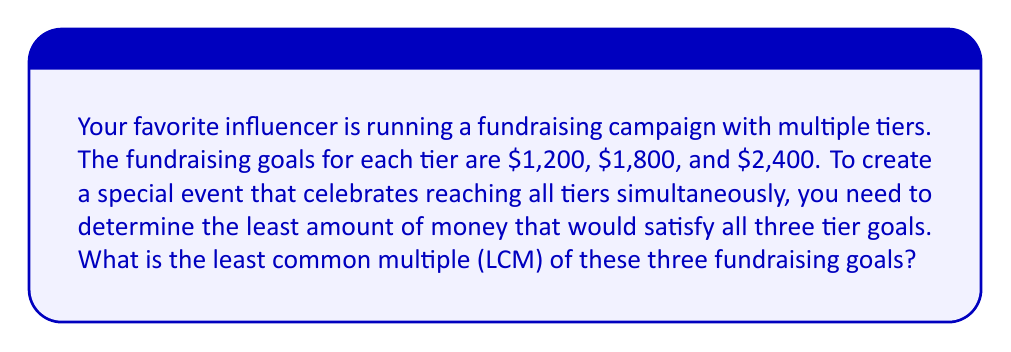Can you answer this question? To find the least common multiple (LCM) of 1200, 1800, and 2400, we'll follow these steps:

1) First, let's factor each number:

   $1200 = 2^4 \times 3 \times 5^2$
   $1800 = 2^3 \times 3^2 \times 5^2$
   $2400 = 2^5 \times 3 \times 5^2$

2) The LCM will include the highest power of each prime factor from these numbers:

   - For 2, the highest power is 5 (from 2400)
   - For 3, the highest power is 2 (from 1800)
   - For 5, the highest power is 2 (common to all)

3) Therefore, the LCM is:

   $LCM = 2^5 \times 3^2 \times 5^2$

4) Let's calculate this:

   $LCM = 32 \times 9 \times 25 = 7200$

Thus, $7,200 is the least amount that satisfies all three fundraising goals simultaneously.
Answer: $7,200 